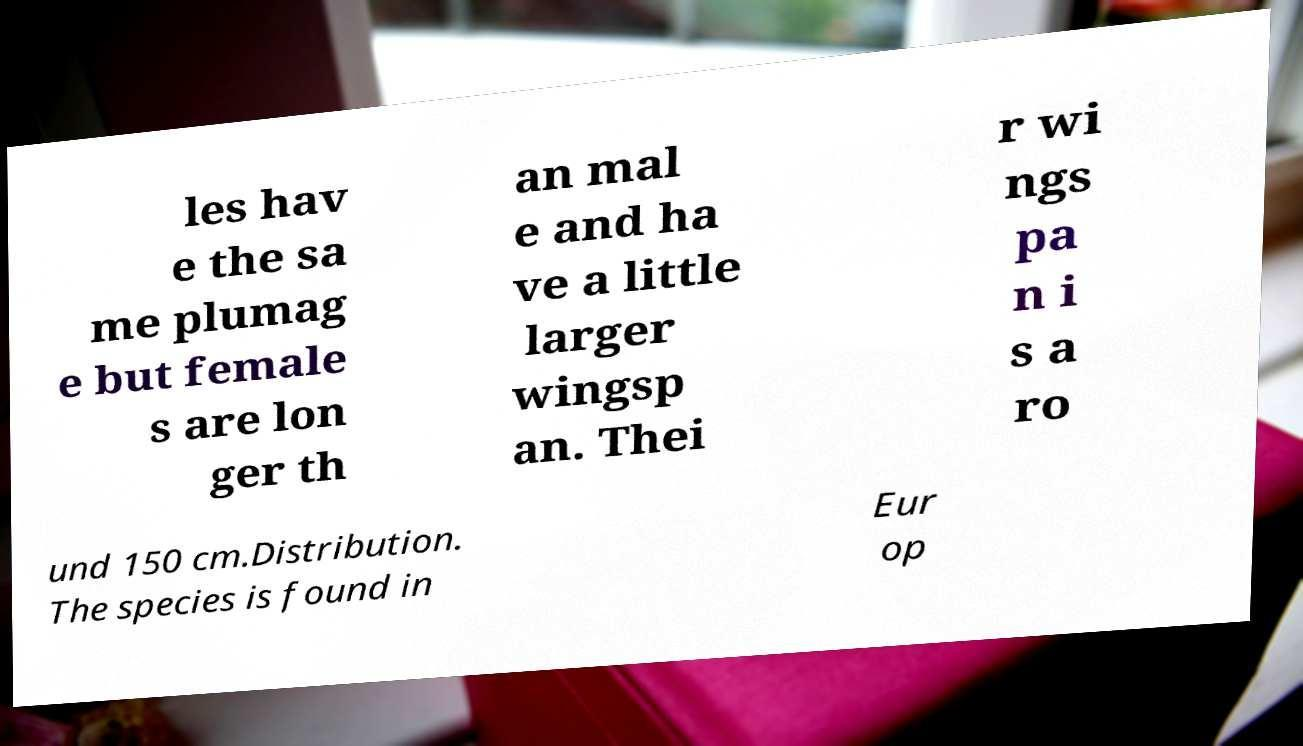What messages or text are displayed in this image? I need them in a readable, typed format. les hav e the sa me plumag e but female s are lon ger th an mal e and ha ve a little larger wingsp an. Thei r wi ngs pa n i s a ro und 150 cm.Distribution. The species is found in Eur op 